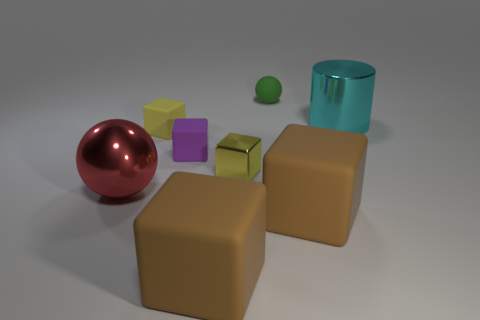Subtract all metal blocks. How many blocks are left? 4 Subtract all brown cubes. How many cubes are left? 3 Subtract all purple cubes. Subtract all purple spheres. How many cubes are left? 4 Add 2 tiny yellow blocks. How many objects exist? 10 Subtract all cylinders. How many objects are left? 7 Add 8 yellow shiny blocks. How many yellow shiny blocks exist? 9 Subtract 0 blue cylinders. How many objects are left? 8 Subtract all small purple rubber things. Subtract all large metal cylinders. How many objects are left? 6 Add 6 tiny matte cubes. How many tiny matte cubes are left? 8 